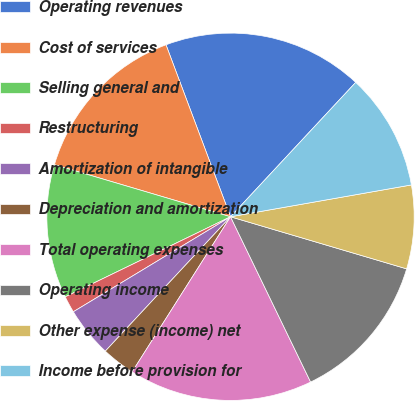Convert chart. <chart><loc_0><loc_0><loc_500><loc_500><pie_chart><fcel>Operating revenues<fcel>Cost of services<fcel>Selling general and<fcel>Restructuring<fcel>Amortization of intangible<fcel>Depreciation and amortization<fcel>Total operating expenses<fcel>Operating income<fcel>Other expense (income) net<fcel>Income before provision for<nl><fcel>17.65%<fcel>14.71%<fcel>11.76%<fcel>1.47%<fcel>4.41%<fcel>2.94%<fcel>16.18%<fcel>13.24%<fcel>7.35%<fcel>10.29%<nl></chart> 